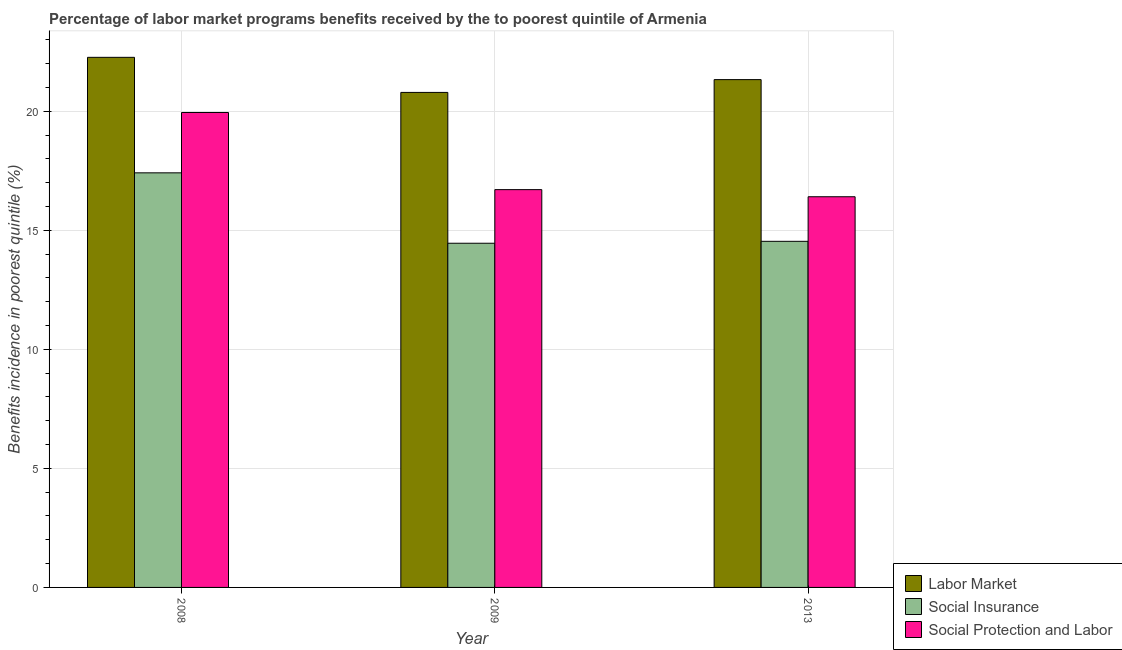How many groups of bars are there?
Offer a very short reply. 3. Are the number of bars per tick equal to the number of legend labels?
Give a very brief answer. Yes. How many bars are there on the 3rd tick from the right?
Make the answer very short. 3. What is the label of the 2nd group of bars from the left?
Your answer should be compact. 2009. In how many cases, is the number of bars for a given year not equal to the number of legend labels?
Your answer should be very brief. 0. What is the percentage of benefits received due to social protection programs in 2009?
Your response must be concise. 16.71. Across all years, what is the maximum percentage of benefits received due to social insurance programs?
Your response must be concise. 17.41. Across all years, what is the minimum percentage of benefits received due to labor market programs?
Keep it short and to the point. 20.79. In which year was the percentage of benefits received due to social insurance programs minimum?
Your response must be concise. 2009. What is the total percentage of benefits received due to labor market programs in the graph?
Your response must be concise. 64.38. What is the difference between the percentage of benefits received due to labor market programs in 2009 and that in 2013?
Keep it short and to the point. -0.54. What is the difference between the percentage of benefits received due to labor market programs in 2013 and the percentage of benefits received due to social insurance programs in 2009?
Provide a succinct answer. 0.54. What is the average percentage of benefits received due to labor market programs per year?
Keep it short and to the point. 21.46. In the year 2013, what is the difference between the percentage of benefits received due to labor market programs and percentage of benefits received due to social insurance programs?
Make the answer very short. 0. What is the ratio of the percentage of benefits received due to social insurance programs in 2008 to that in 2009?
Offer a very short reply. 1.2. Is the difference between the percentage of benefits received due to labor market programs in 2008 and 2013 greater than the difference between the percentage of benefits received due to social insurance programs in 2008 and 2013?
Offer a very short reply. No. What is the difference between the highest and the second highest percentage of benefits received due to labor market programs?
Provide a succinct answer. 0.94. What is the difference between the highest and the lowest percentage of benefits received due to social protection programs?
Provide a short and direct response. 3.54. In how many years, is the percentage of benefits received due to social insurance programs greater than the average percentage of benefits received due to social insurance programs taken over all years?
Keep it short and to the point. 1. Is the sum of the percentage of benefits received due to labor market programs in 2008 and 2013 greater than the maximum percentage of benefits received due to social insurance programs across all years?
Offer a terse response. Yes. What does the 2nd bar from the left in 2013 represents?
Keep it short and to the point. Social Insurance. What does the 3rd bar from the right in 2009 represents?
Offer a terse response. Labor Market. How many bars are there?
Your answer should be very brief. 9. Are all the bars in the graph horizontal?
Offer a very short reply. No. How many years are there in the graph?
Offer a terse response. 3. What is the difference between two consecutive major ticks on the Y-axis?
Offer a terse response. 5. Are the values on the major ticks of Y-axis written in scientific E-notation?
Your answer should be very brief. No. Does the graph contain grids?
Give a very brief answer. Yes. Where does the legend appear in the graph?
Keep it short and to the point. Bottom right. How many legend labels are there?
Your answer should be very brief. 3. How are the legend labels stacked?
Ensure brevity in your answer.  Vertical. What is the title of the graph?
Your answer should be very brief. Percentage of labor market programs benefits received by the to poorest quintile of Armenia. What is the label or title of the Y-axis?
Keep it short and to the point. Benefits incidence in poorest quintile (%). What is the Benefits incidence in poorest quintile (%) of Labor Market in 2008?
Offer a terse response. 22.26. What is the Benefits incidence in poorest quintile (%) in Social Insurance in 2008?
Make the answer very short. 17.41. What is the Benefits incidence in poorest quintile (%) of Social Protection and Labor in 2008?
Offer a terse response. 19.95. What is the Benefits incidence in poorest quintile (%) in Labor Market in 2009?
Give a very brief answer. 20.79. What is the Benefits incidence in poorest quintile (%) in Social Insurance in 2009?
Offer a terse response. 14.45. What is the Benefits incidence in poorest quintile (%) of Social Protection and Labor in 2009?
Make the answer very short. 16.71. What is the Benefits incidence in poorest quintile (%) in Labor Market in 2013?
Your answer should be very brief. 21.33. What is the Benefits incidence in poorest quintile (%) of Social Insurance in 2013?
Provide a succinct answer. 14.54. What is the Benefits incidence in poorest quintile (%) of Social Protection and Labor in 2013?
Your response must be concise. 16.41. Across all years, what is the maximum Benefits incidence in poorest quintile (%) of Labor Market?
Make the answer very short. 22.26. Across all years, what is the maximum Benefits incidence in poorest quintile (%) of Social Insurance?
Your response must be concise. 17.41. Across all years, what is the maximum Benefits incidence in poorest quintile (%) in Social Protection and Labor?
Your answer should be very brief. 19.95. Across all years, what is the minimum Benefits incidence in poorest quintile (%) in Labor Market?
Give a very brief answer. 20.79. Across all years, what is the minimum Benefits incidence in poorest quintile (%) in Social Insurance?
Your answer should be compact. 14.45. Across all years, what is the minimum Benefits incidence in poorest quintile (%) in Social Protection and Labor?
Provide a succinct answer. 16.41. What is the total Benefits incidence in poorest quintile (%) of Labor Market in the graph?
Make the answer very short. 64.38. What is the total Benefits incidence in poorest quintile (%) of Social Insurance in the graph?
Offer a very short reply. 46.4. What is the total Benefits incidence in poorest quintile (%) in Social Protection and Labor in the graph?
Your answer should be compact. 53.06. What is the difference between the Benefits incidence in poorest quintile (%) of Labor Market in 2008 and that in 2009?
Your answer should be very brief. 1.47. What is the difference between the Benefits incidence in poorest quintile (%) of Social Insurance in 2008 and that in 2009?
Make the answer very short. 2.96. What is the difference between the Benefits incidence in poorest quintile (%) of Social Protection and Labor in 2008 and that in 2009?
Offer a very short reply. 3.24. What is the difference between the Benefits incidence in poorest quintile (%) in Labor Market in 2008 and that in 2013?
Ensure brevity in your answer.  0.94. What is the difference between the Benefits incidence in poorest quintile (%) in Social Insurance in 2008 and that in 2013?
Your response must be concise. 2.88. What is the difference between the Benefits incidence in poorest quintile (%) of Social Protection and Labor in 2008 and that in 2013?
Ensure brevity in your answer.  3.54. What is the difference between the Benefits incidence in poorest quintile (%) in Labor Market in 2009 and that in 2013?
Your response must be concise. -0.54. What is the difference between the Benefits incidence in poorest quintile (%) in Social Insurance in 2009 and that in 2013?
Your response must be concise. -0.08. What is the difference between the Benefits incidence in poorest quintile (%) of Social Protection and Labor in 2009 and that in 2013?
Ensure brevity in your answer.  0.3. What is the difference between the Benefits incidence in poorest quintile (%) in Labor Market in 2008 and the Benefits incidence in poorest quintile (%) in Social Insurance in 2009?
Offer a terse response. 7.81. What is the difference between the Benefits incidence in poorest quintile (%) in Labor Market in 2008 and the Benefits incidence in poorest quintile (%) in Social Protection and Labor in 2009?
Ensure brevity in your answer.  5.56. What is the difference between the Benefits incidence in poorest quintile (%) in Social Insurance in 2008 and the Benefits incidence in poorest quintile (%) in Social Protection and Labor in 2009?
Give a very brief answer. 0.71. What is the difference between the Benefits incidence in poorest quintile (%) in Labor Market in 2008 and the Benefits incidence in poorest quintile (%) in Social Insurance in 2013?
Ensure brevity in your answer.  7.73. What is the difference between the Benefits incidence in poorest quintile (%) in Labor Market in 2008 and the Benefits incidence in poorest quintile (%) in Social Protection and Labor in 2013?
Provide a succinct answer. 5.85. What is the difference between the Benefits incidence in poorest quintile (%) in Labor Market in 2009 and the Benefits incidence in poorest quintile (%) in Social Insurance in 2013?
Provide a short and direct response. 6.25. What is the difference between the Benefits incidence in poorest quintile (%) of Labor Market in 2009 and the Benefits incidence in poorest quintile (%) of Social Protection and Labor in 2013?
Your answer should be compact. 4.38. What is the difference between the Benefits incidence in poorest quintile (%) in Social Insurance in 2009 and the Benefits incidence in poorest quintile (%) in Social Protection and Labor in 2013?
Offer a very short reply. -1.95. What is the average Benefits incidence in poorest quintile (%) in Labor Market per year?
Provide a short and direct response. 21.46. What is the average Benefits incidence in poorest quintile (%) of Social Insurance per year?
Provide a succinct answer. 15.47. What is the average Benefits incidence in poorest quintile (%) in Social Protection and Labor per year?
Your answer should be very brief. 17.69. In the year 2008, what is the difference between the Benefits incidence in poorest quintile (%) in Labor Market and Benefits incidence in poorest quintile (%) in Social Insurance?
Ensure brevity in your answer.  4.85. In the year 2008, what is the difference between the Benefits incidence in poorest quintile (%) of Labor Market and Benefits incidence in poorest quintile (%) of Social Protection and Labor?
Provide a short and direct response. 2.32. In the year 2008, what is the difference between the Benefits incidence in poorest quintile (%) in Social Insurance and Benefits incidence in poorest quintile (%) in Social Protection and Labor?
Ensure brevity in your answer.  -2.53. In the year 2009, what is the difference between the Benefits incidence in poorest quintile (%) of Labor Market and Benefits incidence in poorest quintile (%) of Social Insurance?
Provide a short and direct response. 6.33. In the year 2009, what is the difference between the Benefits incidence in poorest quintile (%) of Labor Market and Benefits incidence in poorest quintile (%) of Social Protection and Labor?
Make the answer very short. 4.08. In the year 2009, what is the difference between the Benefits incidence in poorest quintile (%) in Social Insurance and Benefits incidence in poorest quintile (%) in Social Protection and Labor?
Make the answer very short. -2.25. In the year 2013, what is the difference between the Benefits incidence in poorest quintile (%) of Labor Market and Benefits incidence in poorest quintile (%) of Social Insurance?
Keep it short and to the point. 6.79. In the year 2013, what is the difference between the Benefits incidence in poorest quintile (%) in Labor Market and Benefits incidence in poorest quintile (%) in Social Protection and Labor?
Keep it short and to the point. 4.92. In the year 2013, what is the difference between the Benefits incidence in poorest quintile (%) in Social Insurance and Benefits incidence in poorest quintile (%) in Social Protection and Labor?
Keep it short and to the point. -1.87. What is the ratio of the Benefits incidence in poorest quintile (%) in Labor Market in 2008 to that in 2009?
Your answer should be compact. 1.07. What is the ratio of the Benefits incidence in poorest quintile (%) of Social Insurance in 2008 to that in 2009?
Offer a terse response. 1.2. What is the ratio of the Benefits incidence in poorest quintile (%) in Social Protection and Labor in 2008 to that in 2009?
Ensure brevity in your answer.  1.19. What is the ratio of the Benefits incidence in poorest quintile (%) of Labor Market in 2008 to that in 2013?
Provide a succinct answer. 1.04. What is the ratio of the Benefits incidence in poorest quintile (%) in Social Insurance in 2008 to that in 2013?
Make the answer very short. 1.2. What is the ratio of the Benefits incidence in poorest quintile (%) in Social Protection and Labor in 2008 to that in 2013?
Provide a succinct answer. 1.22. What is the ratio of the Benefits incidence in poorest quintile (%) of Labor Market in 2009 to that in 2013?
Your response must be concise. 0.97. What is the ratio of the Benefits incidence in poorest quintile (%) of Social Insurance in 2009 to that in 2013?
Your answer should be very brief. 0.99. What is the ratio of the Benefits incidence in poorest quintile (%) in Social Protection and Labor in 2009 to that in 2013?
Make the answer very short. 1.02. What is the difference between the highest and the second highest Benefits incidence in poorest quintile (%) of Labor Market?
Your answer should be compact. 0.94. What is the difference between the highest and the second highest Benefits incidence in poorest quintile (%) in Social Insurance?
Your response must be concise. 2.88. What is the difference between the highest and the second highest Benefits incidence in poorest quintile (%) of Social Protection and Labor?
Ensure brevity in your answer.  3.24. What is the difference between the highest and the lowest Benefits incidence in poorest quintile (%) in Labor Market?
Give a very brief answer. 1.47. What is the difference between the highest and the lowest Benefits incidence in poorest quintile (%) in Social Insurance?
Ensure brevity in your answer.  2.96. What is the difference between the highest and the lowest Benefits incidence in poorest quintile (%) of Social Protection and Labor?
Provide a succinct answer. 3.54. 